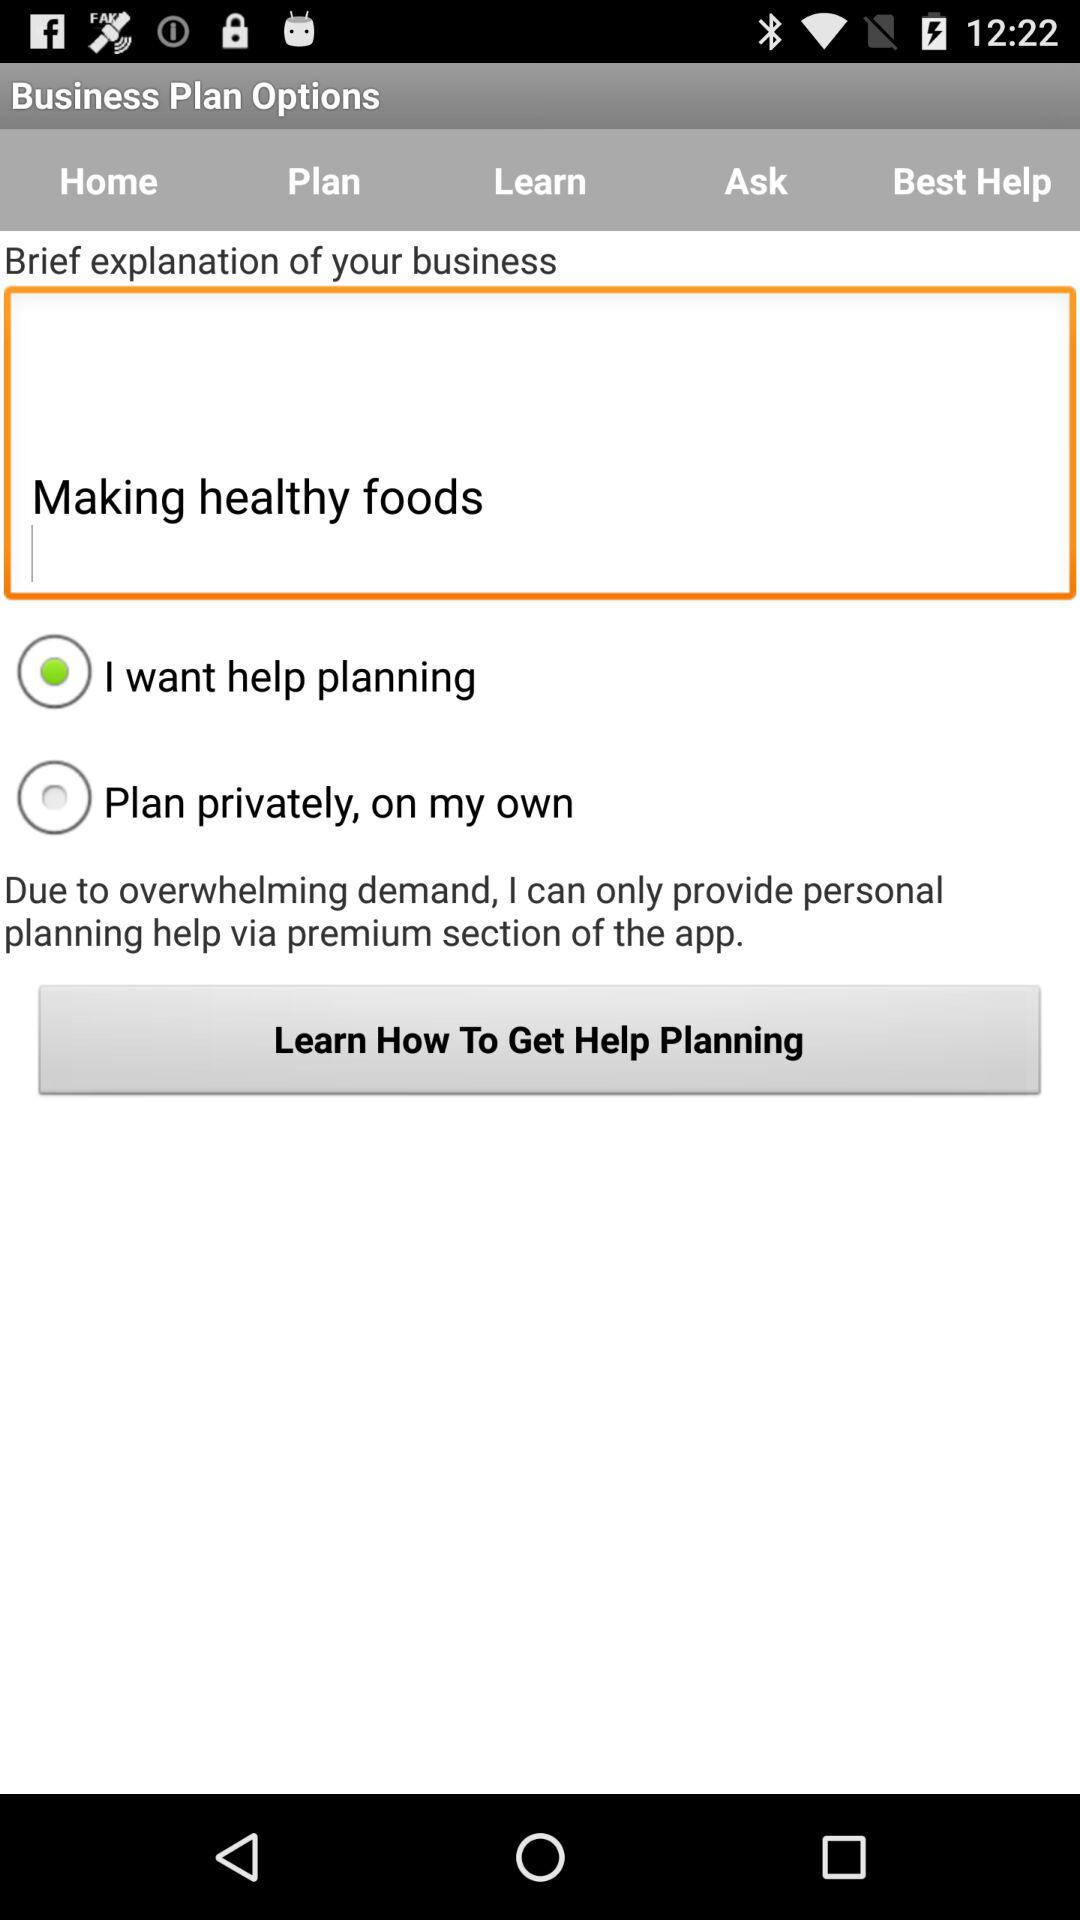Which option was selected? The selected option was "I want help planning". 